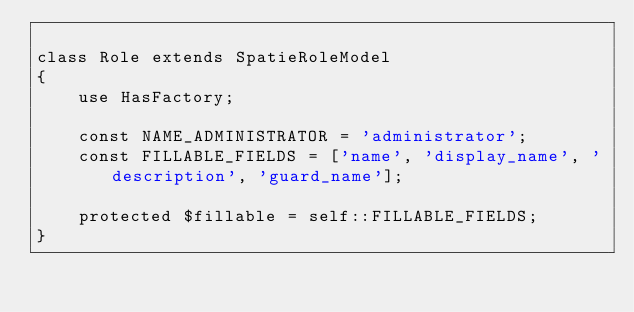Convert code to text. <code><loc_0><loc_0><loc_500><loc_500><_PHP_>
class Role extends SpatieRoleModel
{
    use HasFactory;

    const NAME_ADMINISTRATOR = 'administrator';
    const FILLABLE_FIELDS = ['name', 'display_name', 'description', 'guard_name'];

    protected $fillable = self::FILLABLE_FIELDS;
}
</code> 